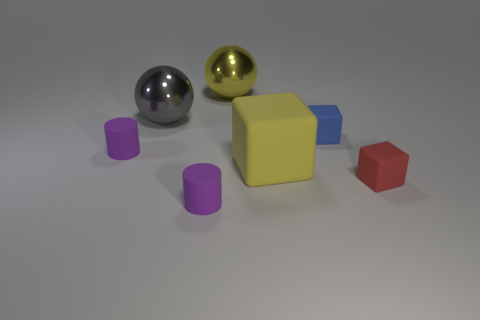What material is the thing that is the same color as the big rubber cube?
Your response must be concise. Metal. Does the purple rubber thing that is in front of the yellow block have the same size as the cylinder on the left side of the big gray metal object?
Give a very brief answer. Yes. There is a big yellow thing that is behind the tiny blue block; what is its shape?
Your response must be concise. Sphere. What is the material of the big yellow thing that is the same shape as the gray thing?
Your answer should be very brief. Metal. There is a metallic object left of the yellow shiny thing; does it have the same size as the big yellow metallic sphere?
Your answer should be very brief. Yes. There is a tiny blue rubber cube; what number of large yellow rubber blocks are right of it?
Provide a succinct answer. 0. Are there fewer tiny purple objects that are right of the blue matte thing than yellow things in front of the large yellow rubber block?
Your response must be concise. No. How many big blocks are there?
Offer a very short reply. 1. There is a tiny matte block in front of the small blue rubber block; what is its color?
Offer a terse response. Red. The yellow block is what size?
Offer a terse response. Large. 